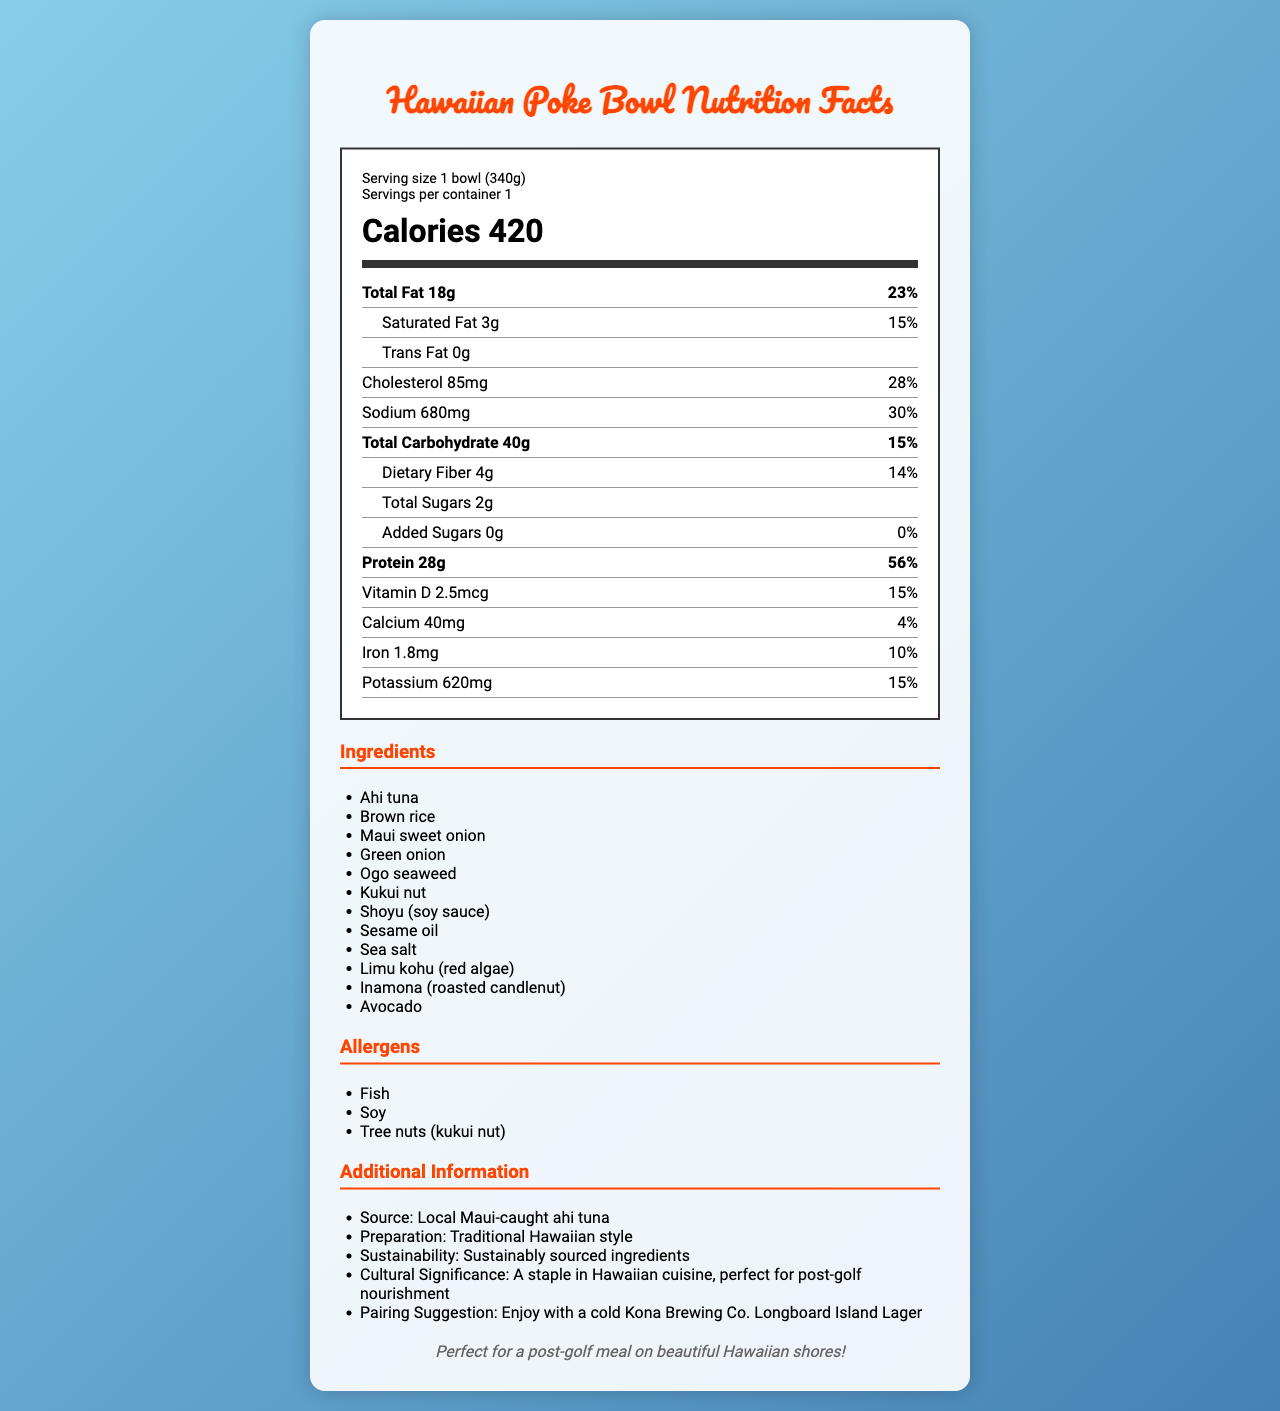what is the serving size of the poke bowl? The serving size is indicated at the beginning of the nutrition label, specified as "1 bowl (340g)".
Answer: 1 bowl (340g) how many calories are in one serving of the poke bowl? The calories per serving are prominently displayed in large font in the middle of the nutrition label, specified as "Calories 420".
Answer: 420 what is the total fat content per serving? The total fat content is listed under the nutrients section and is indicated as "Total Fat 18g".
Answer: 18g how much protein is there in one serving of the poke bowl? The protein content is listed near the end of the nutrients section as "Protein 28g".
Answer: 28g what allergens are present in the poke bowl? The allergens are listed under the allergens section with the specified items "Fish, Soy, Tree nuts (kukui nut)".
Answer: Fish, Soy, Tree nuts (kukui nut) how much sodium is in one serving of the poke bowl? A. 480mg B. 680mg C. 780mg D. 580mg The sodium content is provided in the nutrients section as "Sodium 680mg".
Answer: B. 680mg which vitamin has the highest percentage of daily value per serving? A. Vitamin D B. Calcium C. Iron D. Potassium Vitamin D has the highest percentage of daily value at 15%, whereas the other vitamins and minerals have lower percentages: Calcium (4%), Iron (10%), Potassium (15%).
Answer: A. Vitamin D is there any trans fat in the poke bowl? The amount of trans fat is listed as "0g" under the saturated fat sub-section of the total fat category.
Answer: No what is the source of the ahi tuna used in the poke bowl? The source is mentioned in the additional information section as "Local Maui-caught ahi tuna".
Answer: Local Maui-caught ahi tuna summarize the information provided in the document. The nutrition label lists detailed information about the serving size, calories, and various nutrients. Additionally, it includes a list of ingredients used, potential allergens, and extra details about the poke bowl's origin and suggested pairing.
Answer: The document provides the nutrition facts for a traditional Hawaiian poke bowl, including serving size, calories, macronutrients, micronutrients, ingredients, allergens, and additional information about the source, preparation, sustainability, cultural significance, and pairing suggestions. how long does it take to prepare the poke bowl? The document does not provide any information regarding the preparation time of the poke bowl.
Answer: Not enough information 